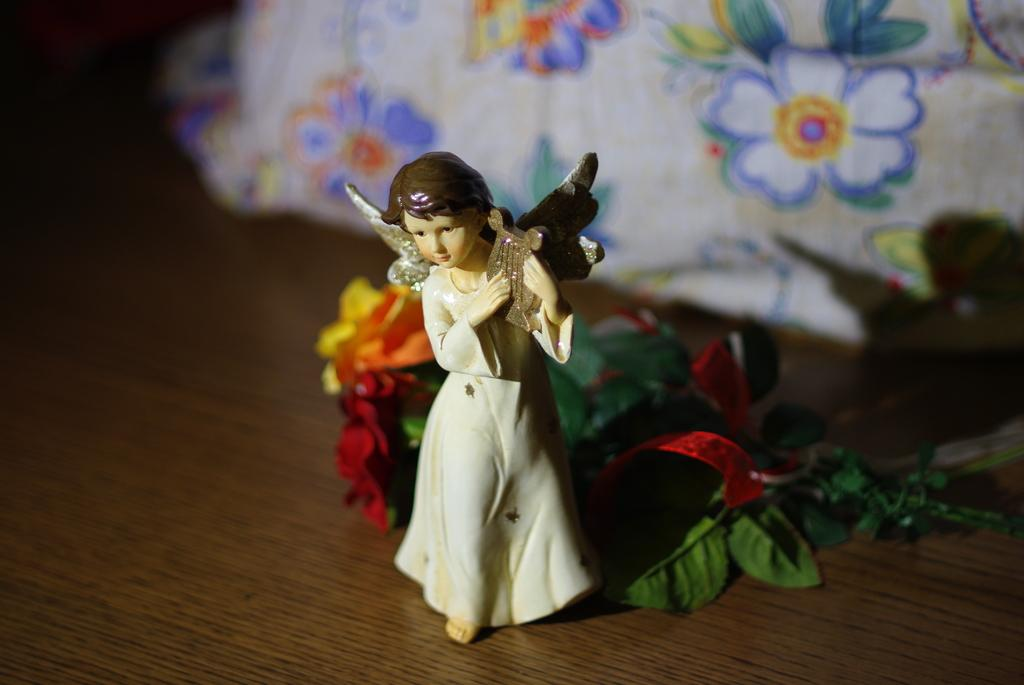What is the main subject in the center of the image? There is a toy in the center of the image. What can be seen on the table in the image? There are flowers on the table. What is visible in the background of the image? There is a cloth with flowers in the background of the image. What type of laborer is working in the image? There is no laborer present in the image. Can you describe the actor's performance in the image? There is no actor present in the image. 